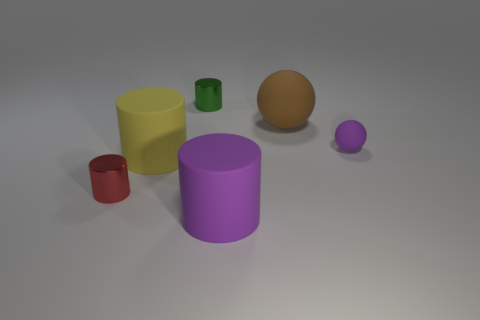Add 1 large brown rubber things. How many objects exist? 7 Subtract all purple cylinders. How many cylinders are left? 3 Subtract all cylinders. How many objects are left? 2 Subtract 2 cylinders. How many cylinders are left? 2 Subtract all cyan balls. Subtract all green cubes. How many balls are left? 2 Subtract all blue cylinders. How many purple balls are left? 1 Subtract all big cylinders. Subtract all small purple balls. How many objects are left? 3 Add 6 yellow cylinders. How many yellow cylinders are left? 7 Add 3 brown balls. How many brown balls exist? 4 Subtract 1 brown spheres. How many objects are left? 5 